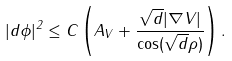Convert formula to latex. <formula><loc_0><loc_0><loc_500><loc_500>| d \phi | ^ { 2 } \leq C \left ( A _ { V } + \frac { \sqrt { d } | \nabla V | } { \cos ( \sqrt { d } \rho ) } \right ) .</formula> 